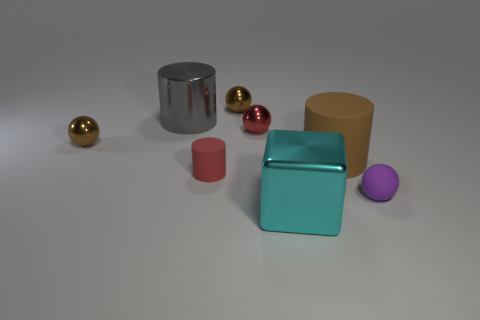Subtract all brown rubber cylinders. How many cylinders are left? 2 Subtract all purple balls. How many balls are left? 3 Subtract 0 yellow cubes. How many objects are left? 8 Subtract all cubes. How many objects are left? 7 Subtract 1 blocks. How many blocks are left? 0 Subtract all red balls. Subtract all brown cylinders. How many balls are left? 3 Subtract all gray blocks. How many red cylinders are left? 1 Subtract all cubes. Subtract all shiny spheres. How many objects are left? 4 Add 3 cyan metallic blocks. How many cyan metallic blocks are left? 4 Add 6 large green metal balls. How many large green metal balls exist? 6 